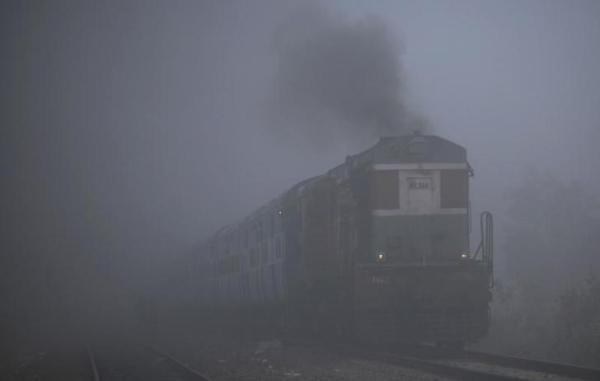What type of locomotive is visible in this foggy setting? The image shows a diesel locomotive, identifiable by the characteristic exhaust plume. Can you describe the weather conditions in the image? The weather appears to be quite foggy, which typically indicates high relative humidity and cool air temperatures, creating a misty atmosphere around the train. 